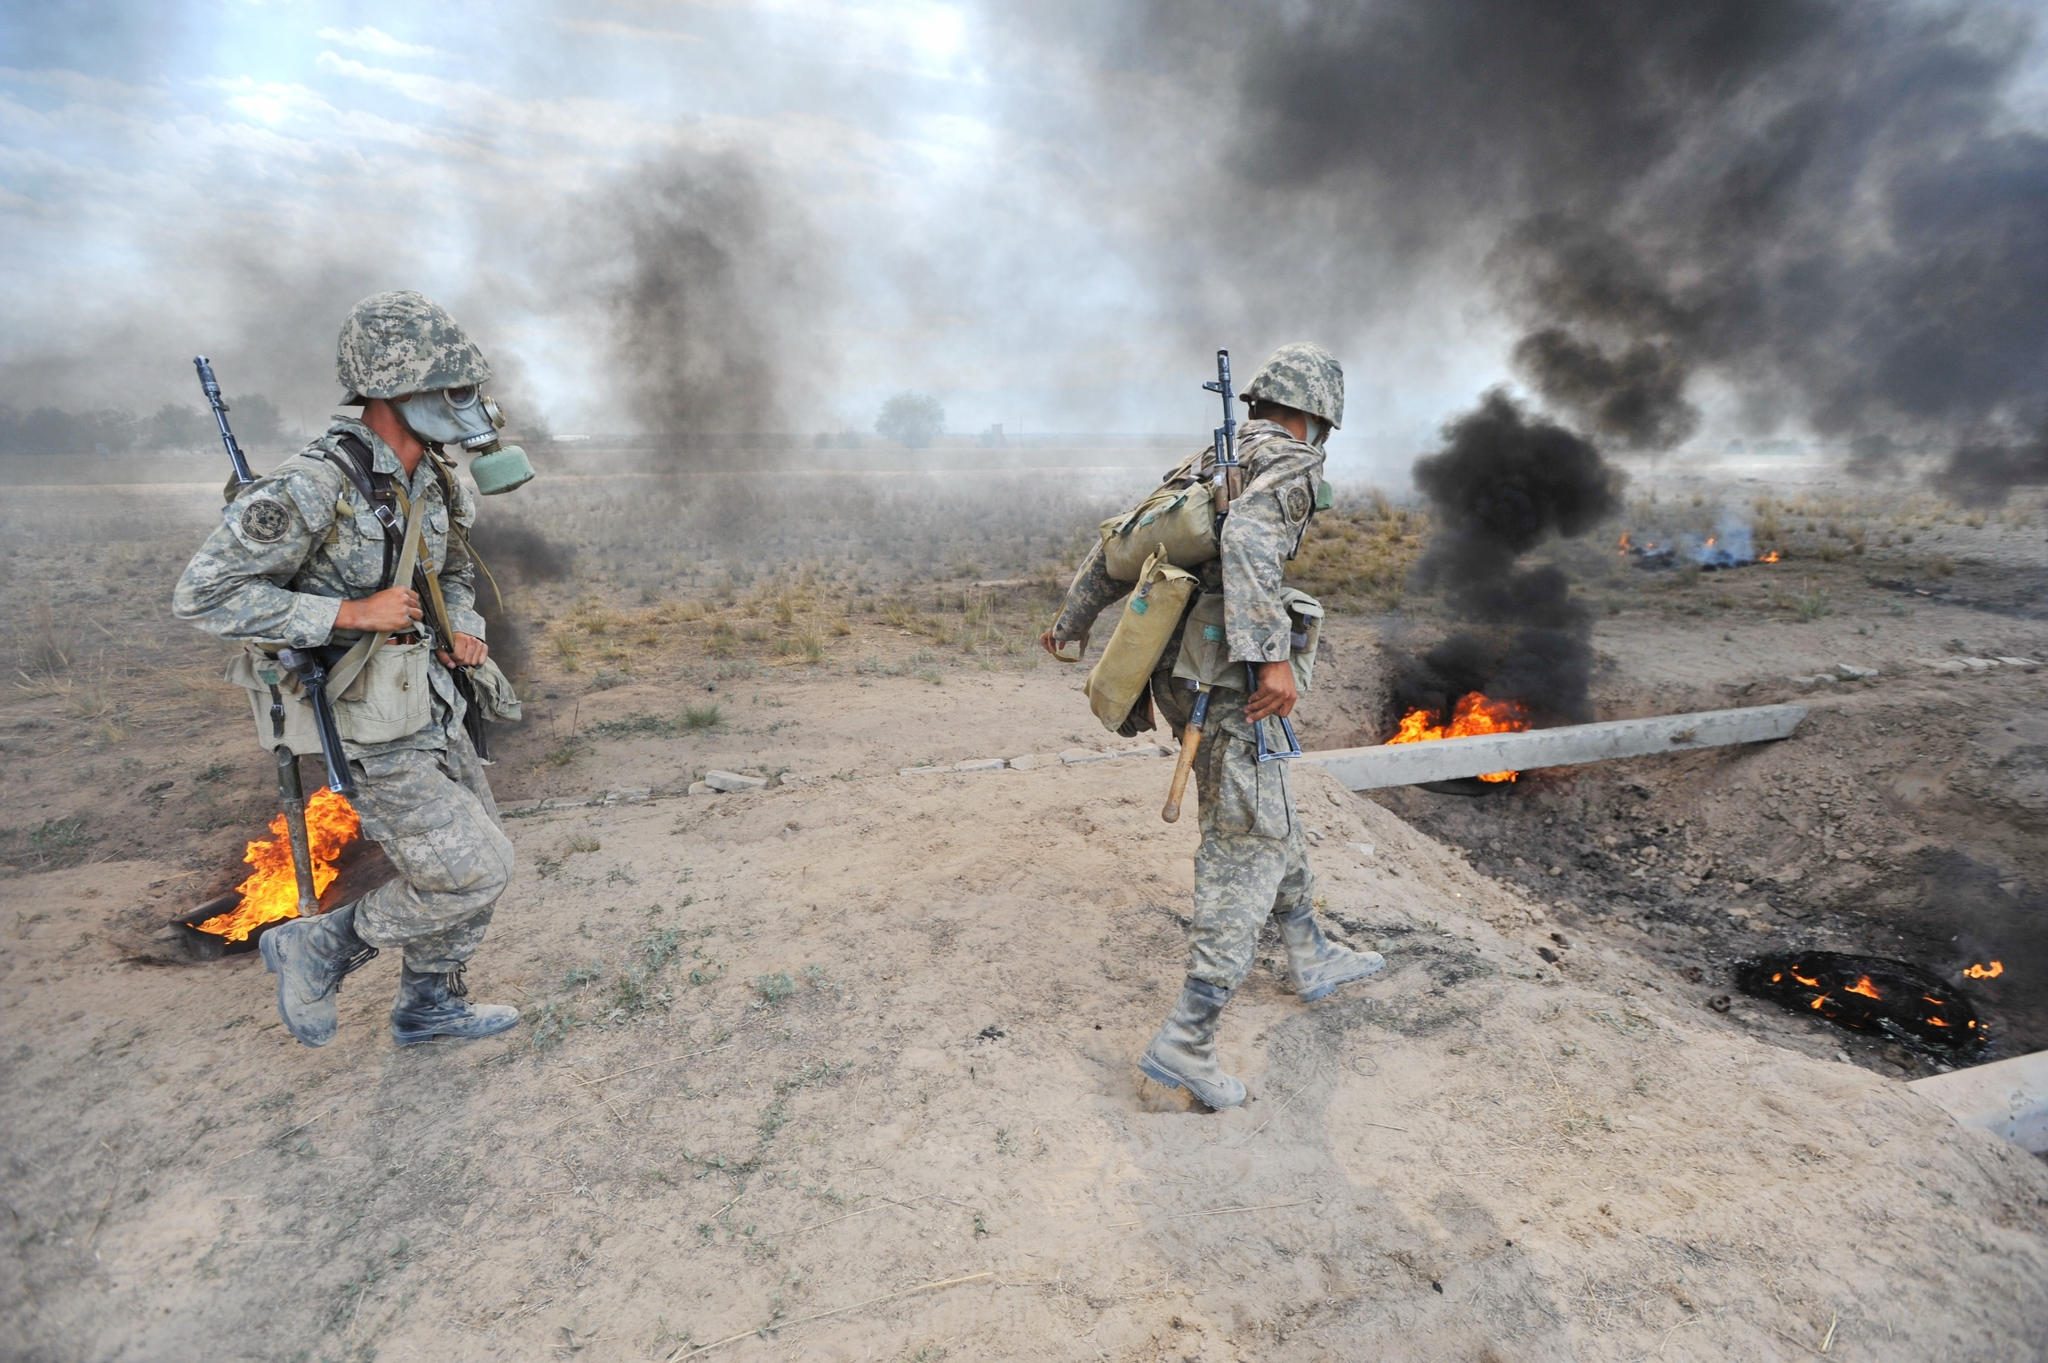Can you describe the main features of this image for me? The image portrays a dramatic scene where two soldiers, clad in camouflage uniforms and equipped with rifles, are moving away from an area filled with smoke and flames. The soldiers appear well-prepared and ready for action, indicating they are part of a military operation or conflict. The ground is scattered with debris, with flames and smoke dominating the background, suggesting a recent explosion or combat situation. The perspective of the image is from below, emphasizing the magnitude and intensity of the scenario. The bright flames starkly contrast with the dark smoke, creating a tense and urgent atmosphere. It's possible the soldiers are completing a mission or evacuating the area, although further context about the specific event or location is not provided. 